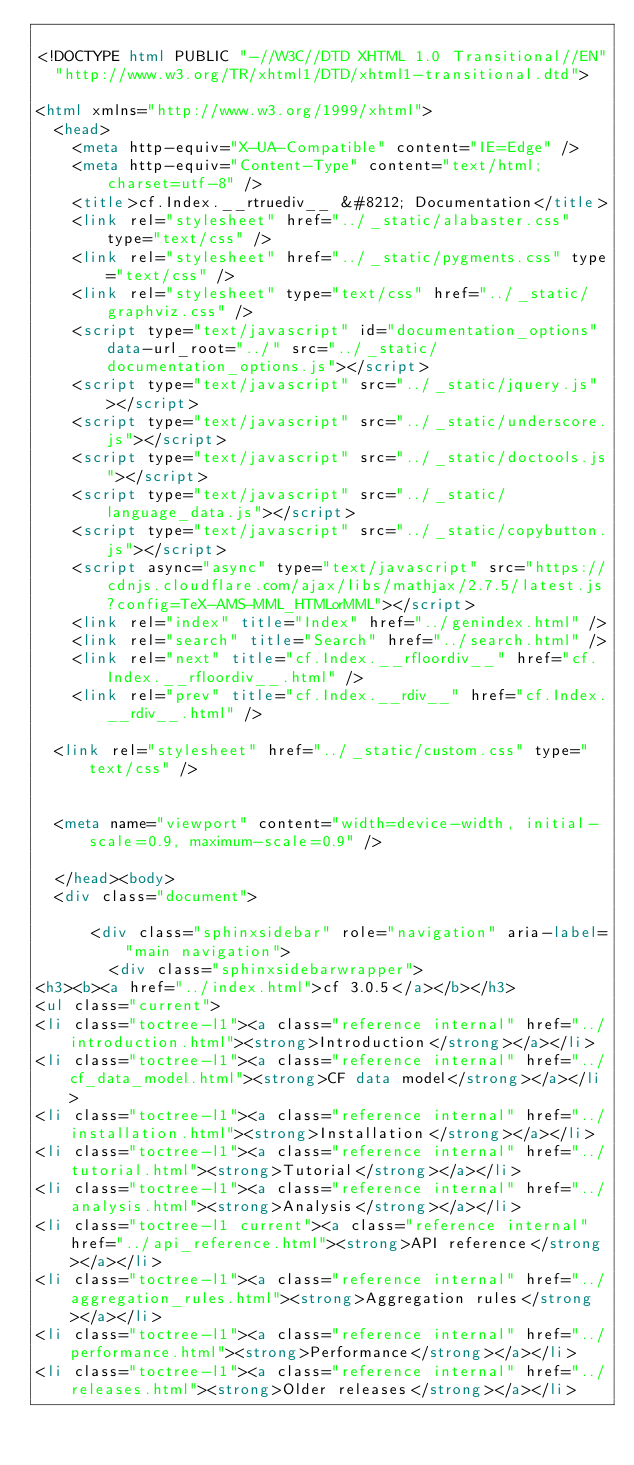<code> <loc_0><loc_0><loc_500><loc_500><_HTML_>
<!DOCTYPE html PUBLIC "-//W3C//DTD XHTML 1.0 Transitional//EN"
  "http://www.w3.org/TR/xhtml1/DTD/xhtml1-transitional.dtd">

<html xmlns="http://www.w3.org/1999/xhtml">
  <head>
    <meta http-equiv="X-UA-Compatible" content="IE=Edge" />
    <meta http-equiv="Content-Type" content="text/html; charset=utf-8" />
    <title>cf.Index.__rtruediv__ &#8212; Documentation</title>
    <link rel="stylesheet" href="../_static/alabaster.css" type="text/css" />
    <link rel="stylesheet" href="../_static/pygments.css" type="text/css" />
    <link rel="stylesheet" type="text/css" href="../_static/graphviz.css" />
    <script type="text/javascript" id="documentation_options" data-url_root="../" src="../_static/documentation_options.js"></script>
    <script type="text/javascript" src="../_static/jquery.js"></script>
    <script type="text/javascript" src="../_static/underscore.js"></script>
    <script type="text/javascript" src="../_static/doctools.js"></script>
    <script type="text/javascript" src="../_static/language_data.js"></script>
    <script type="text/javascript" src="../_static/copybutton.js"></script>
    <script async="async" type="text/javascript" src="https://cdnjs.cloudflare.com/ajax/libs/mathjax/2.7.5/latest.js?config=TeX-AMS-MML_HTMLorMML"></script>
    <link rel="index" title="Index" href="../genindex.html" />
    <link rel="search" title="Search" href="../search.html" />
    <link rel="next" title="cf.Index.__rfloordiv__" href="cf.Index.__rfloordiv__.html" />
    <link rel="prev" title="cf.Index.__rdiv__" href="cf.Index.__rdiv__.html" />
   
  <link rel="stylesheet" href="../_static/custom.css" type="text/css" />
  
  
  <meta name="viewport" content="width=device-width, initial-scale=0.9, maximum-scale=0.9" />

  </head><body>
  <div class="document">
    
      <div class="sphinxsidebar" role="navigation" aria-label="main navigation">
        <div class="sphinxsidebarwrapper">
<h3><b><a href="../index.html">cf 3.0.5</a></b></h3>
<ul class="current">
<li class="toctree-l1"><a class="reference internal" href="../introduction.html"><strong>Introduction</strong></a></li>
<li class="toctree-l1"><a class="reference internal" href="../cf_data_model.html"><strong>CF data model</strong></a></li>
<li class="toctree-l1"><a class="reference internal" href="../installation.html"><strong>Installation</strong></a></li>
<li class="toctree-l1"><a class="reference internal" href="../tutorial.html"><strong>Tutorial</strong></a></li>
<li class="toctree-l1"><a class="reference internal" href="../analysis.html"><strong>Analysis</strong></a></li>
<li class="toctree-l1 current"><a class="reference internal" href="../api_reference.html"><strong>API reference</strong></a></li>
<li class="toctree-l1"><a class="reference internal" href="../aggregation_rules.html"><strong>Aggregation rules</strong></a></li>
<li class="toctree-l1"><a class="reference internal" href="../performance.html"><strong>Performance</strong></a></li>
<li class="toctree-l1"><a class="reference internal" href="../releases.html"><strong>Older releases</strong></a></li></code> 